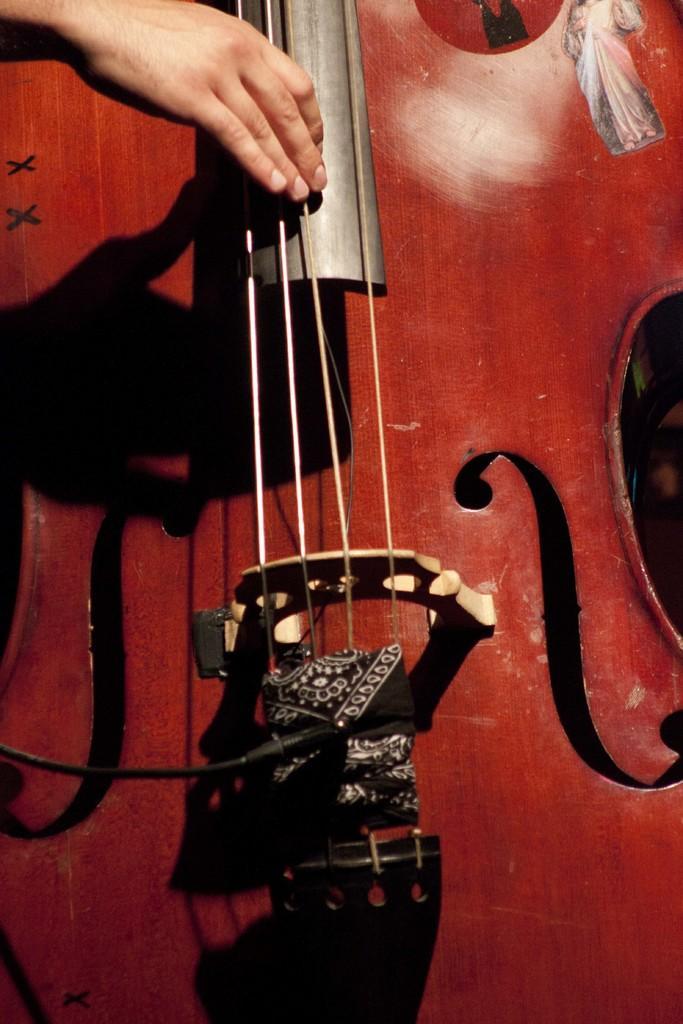In one or two sentences, can you explain what this image depicts? In this picture we can see a musical instrument. In the top left corner we can see a person hand. 